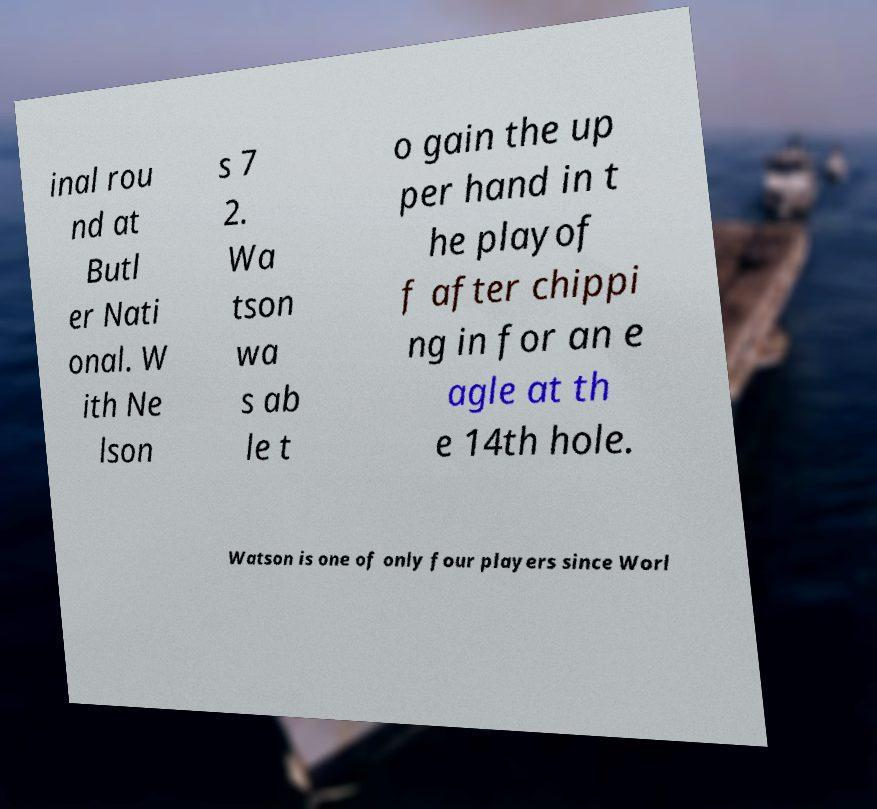There's text embedded in this image that I need extracted. Can you transcribe it verbatim? inal rou nd at Butl er Nati onal. W ith Ne lson s 7 2. Wa tson wa s ab le t o gain the up per hand in t he playof f after chippi ng in for an e agle at th e 14th hole. Watson is one of only four players since Worl 